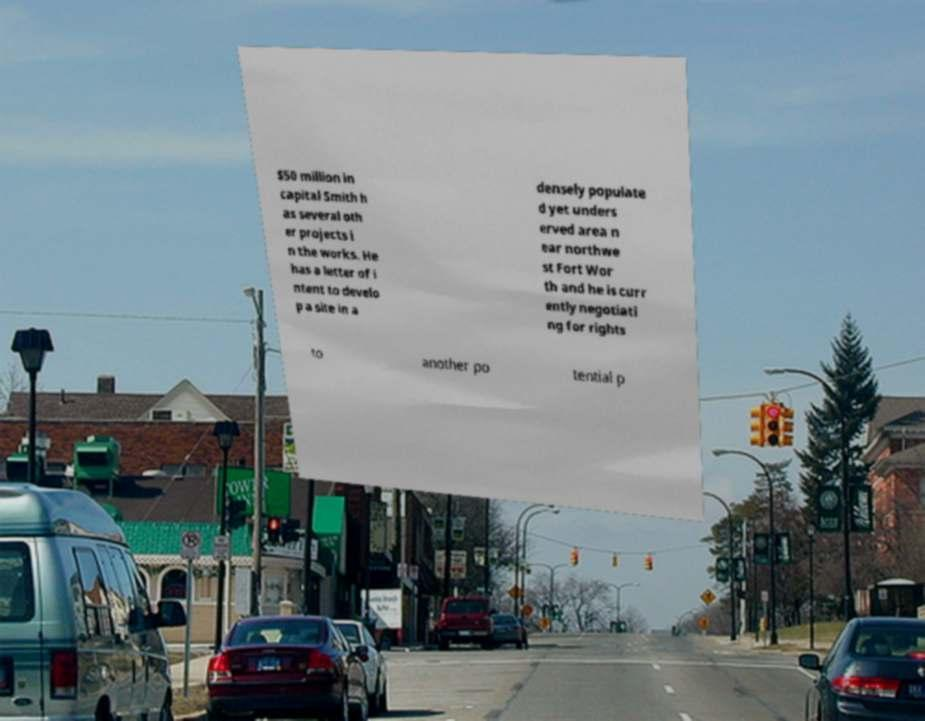Please identify and transcribe the text found in this image. $50 million in capital Smith h as several oth er projects i n the works. He has a letter of i ntent to develo p a site in a densely populate d yet unders erved area n ear northwe st Fort Wor th and he is curr ently negotiati ng for rights to another po tential p 